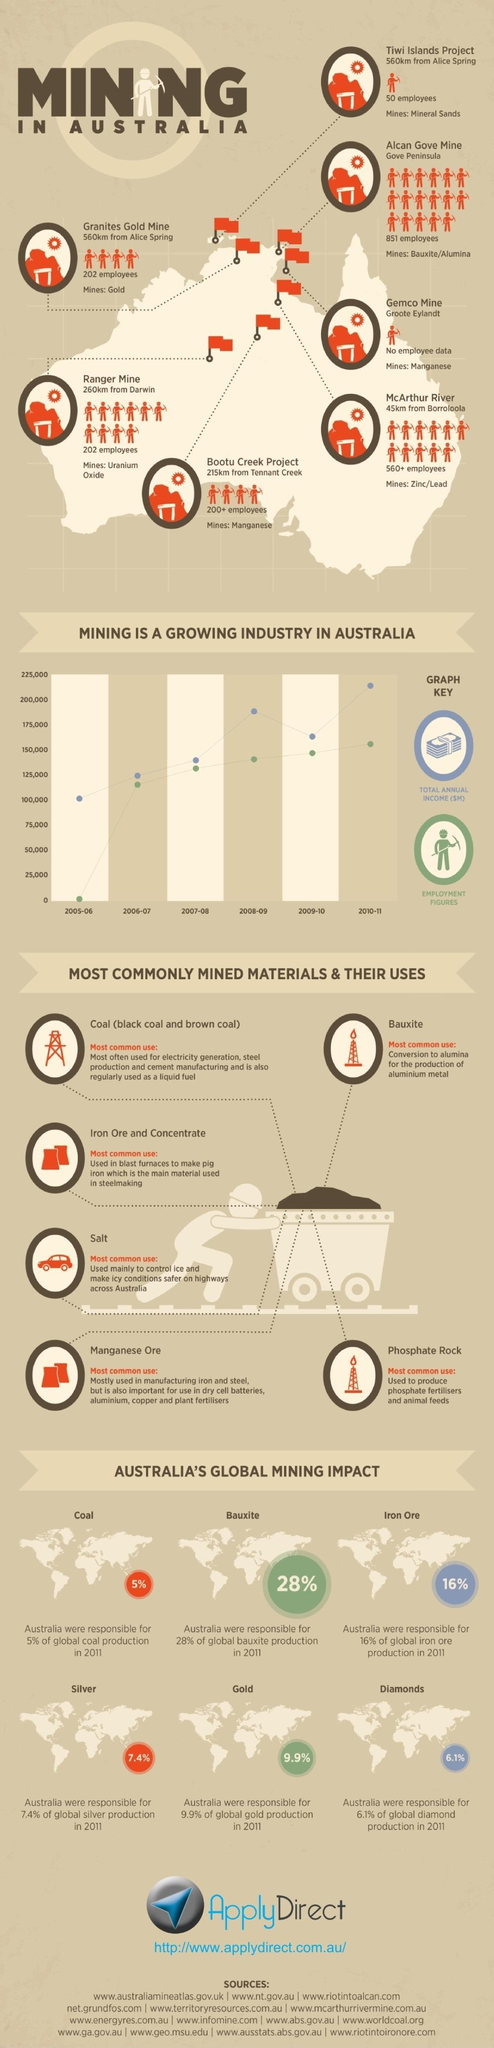What percentage of global silver production is not from Australia in the year 2011?
Answer the question with a short phrase. 92.6% What percentage of global iron ore production is not from Australia in the year 2011? 84% What percentage of global diamond production is not from Australia in the year 2011? 93.9% What percentage of global gold production is not from Australia in the year 2011? 90.1% What percentage of global coal production is not from Australia in the year 2011? 95% What percentage of bauxite production is not from Australia in the year 2011? 72% 